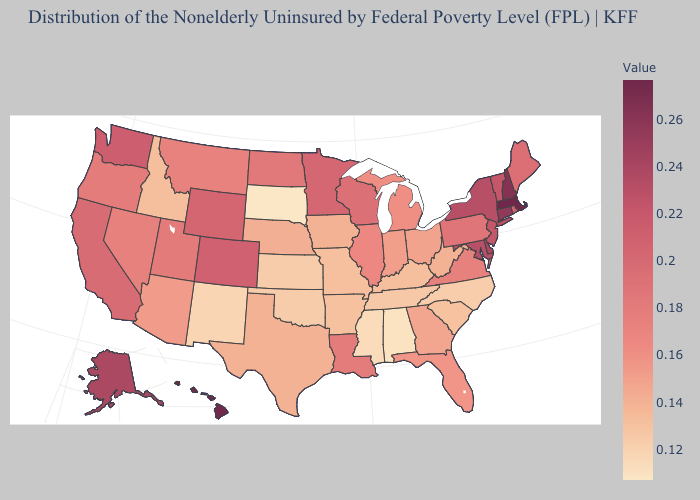Which states have the highest value in the USA?
Short answer required. Massachusetts. Which states have the highest value in the USA?
Short answer required. Massachusetts. Does Hawaii have a lower value than Idaho?
Give a very brief answer. No. Does the map have missing data?
Answer briefly. No. Does Ohio have the highest value in the MidWest?
Be succinct. No. Which states have the lowest value in the USA?
Keep it brief. South Dakota. Among the states that border Georgia , does North Carolina have the highest value?
Give a very brief answer. No. Which states have the lowest value in the USA?
Give a very brief answer. South Dakota. Does the map have missing data?
Give a very brief answer. No. 